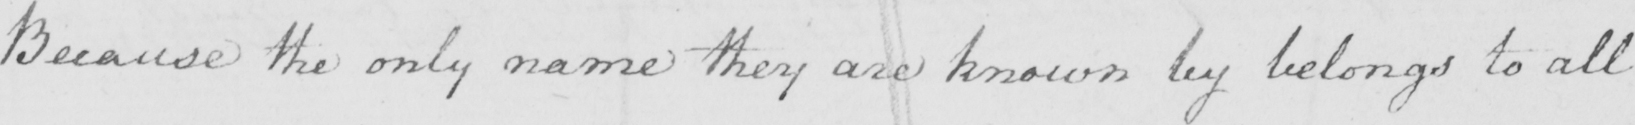What text is written in this handwritten line? Because the only name they are known by belongs to all 